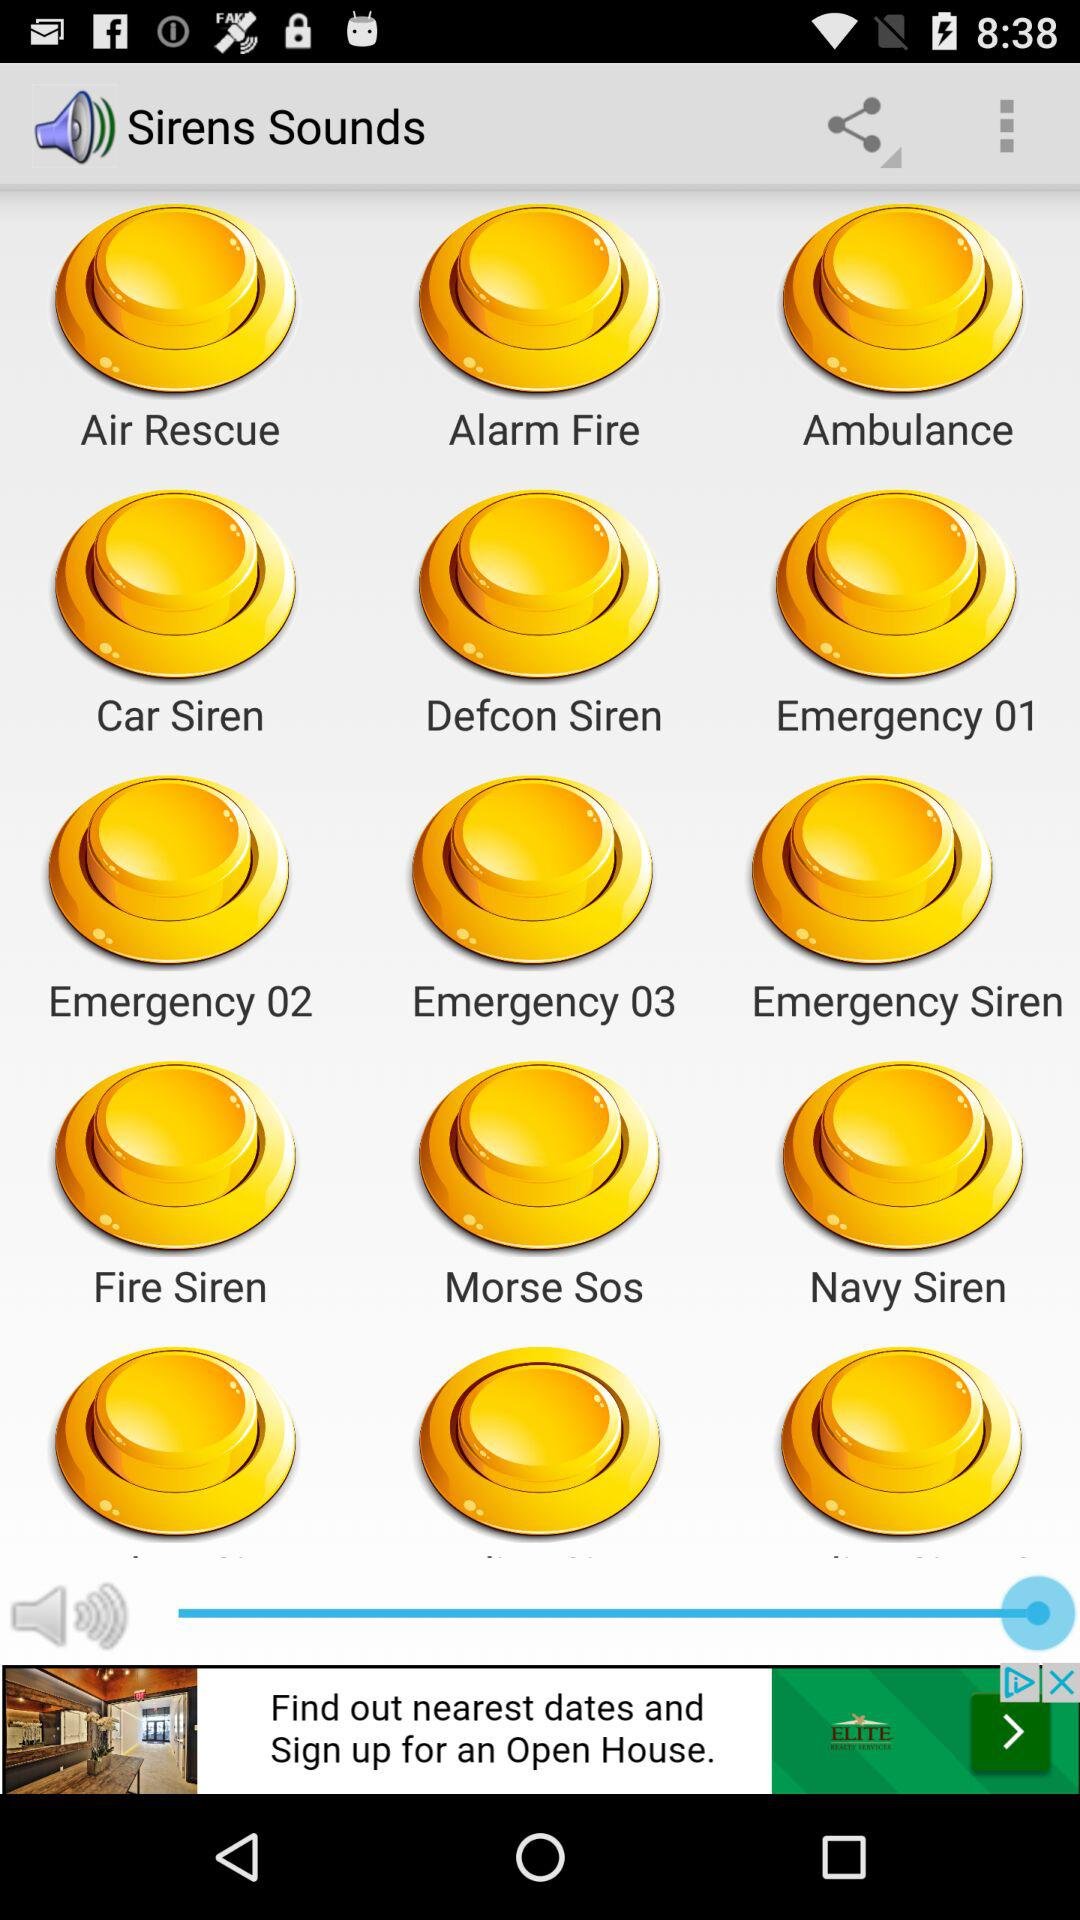What types of "Siren Sounds" are there? The types of "Siren Sounds" are "Air Rescue", "Alarm Fire", "Ambulance", "Car Siren", "Defcon Siren", "Emergency 01", "Emergency 02", "Emergency 03", "Emergency Siren", "Fire Siren", "Morse Sos" and "Navy Siren". 